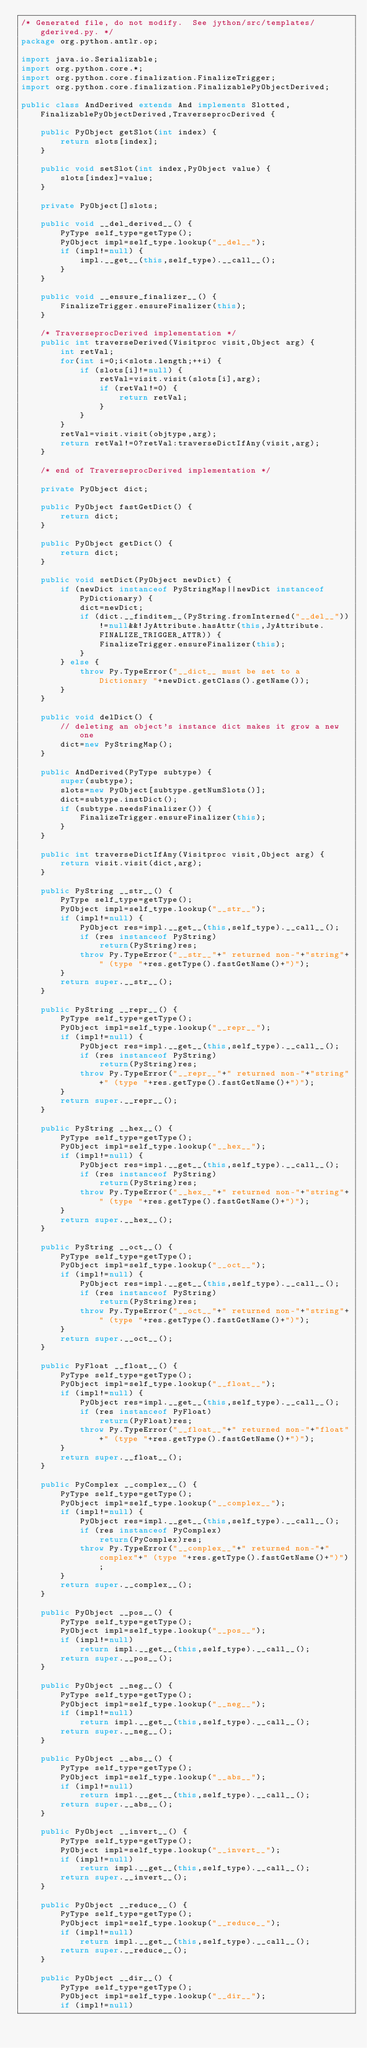Convert code to text. <code><loc_0><loc_0><loc_500><loc_500><_Java_>/* Generated file, do not modify.  See jython/src/templates/gderived.py. */
package org.python.antlr.op;

import java.io.Serializable;
import org.python.core.*;
import org.python.core.finalization.FinalizeTrigger;
import org.python.core.finalization.FinalizablePyObjectDerived;

public class AndDerived extends And implements Slotted,FinalizablePyObjectDerived,TraverseprocDerived {

    public PyObject getSlot(int index) {
        return slots[index];
    }

    public void setSlot(int index,PyObject value) {
        slots[index]=value;
    }

    private PyObject[]slots;

    public void __del_derived__() {
        PyType self_type=getType();
        PyObject impl=self_type.lookup("__del__");
        if (impl!=null) {
            impl.__get__(this,self_type).__call__();
        }
    }

    public void __ensure_finalizer__() {
        FinalizeTrigger.ensureFinalizer(this);
    }

    /* TraverseprocDerived implementation */
    public int traverseDerived(Visitproc visit,Object arg) {
        int retVal;
        for(int i=0;i<slots.length;++i) {
            if (slots[i]!=null) {
                retVal=visit.visit(slots[i],arg);
                if (retVal!=0) {
                    return retVal;
                }
            }
        }
        retVal=visit.visit(objtype,arg);
        return retVal!=0?retVal:traverseDictIfAny(visit,arg);
    }

    /* end of TraverseprocDerived implementation */

    private PyObject dict;

    public PyObject fastGetDict() {
        return dict;
    }

    public PyObject getDict() {
        return dict;
    }

    public void setDict(PyObject newDict) {
        if (newDict instanceof PyStringMap||newDict instanceof PyDictionary) {
            dict=newDict;
            if (dict.__finditem__(PyString.fromInterned("__del__"))!=null&&!JyAttribute.hasAttr(this,JyAttribute.FINALIZE_TRIGGER_ATTR)) {
                FinalizeTrigger.ensureFinalizer(this);
            }
        } else {
            throw Py.TypeError("__dict__ must be set to a Dictionary "+newDict.getClass().getName());
        }
    }

    public void delDict() {
        // deleting an object's instance dict makes it grow a new one
        dict=new PyStringMap();
    }

    public AndDerived(PyType subtype) {
        super(subtype);
        slots=new PyObject[subtype.getNumSlots()];
        dict=subtype.instDict();
        if (subtype.needsFinalizer()) {
            FinalizeTrigger.ensureFinalizer(this);
        }
    }

    public int traverseDictIfAny(Visitproc visit,Object arg) {
        return visit.visit(dict,arg);
    }

    public PyString __str__() {
        PyType self_type=getType();
        PyObject impl=self_type.lookup("__str__");
        if (impl!=null) {
            PyObject res=impl.__get__(this,self_type).__call__();
            if (res instanceof PyString)
                return(PyString)res;
            throw Py.TypeError("__str__"+" returned non-"+"string"+" (type "+res.getType().fastGetName()+")");
        }
        return super.__str__();
    }

    public PyString __repr__() {
        PyType self_type=getType();
        PyObject impl=self_type.lookup("__repr__");
        if (impl!=null) {
            PyObject res=impl.__get__(this,self_type).__call__();
            if (res instanceof PyString)
                return(PyString)res;
            throw Py.TypeError("__repr__"+" returned non-"+"string"+" (type "+res.getType().fastGetName()+")");
        }
        return super.__repr__();
    }

    public PyString __hex__() {
        PyType self_type=getType();
        PyObject impl=self_type.lookup("__hex__");
        if (impl!=null) {
            PyObject res=impl.__get__(this,self_type).__call__();
            if (res instanceof PyString)
                return(PyString)res;
            throw Py.TypeError("__hex__"+" returned non-"+"string"+" (type "+res.getType().fastGetName()+")");
        }
        return super.__hex__();
    }

    public PyString __oct__() {
        PyType self_type=getType();
        PyObject impl=self_type.lookup("__oct__");
        if (impl!=null) {
            PyObject res=impl.__get__(this,self_type).__call__();
            if (res instanceof PyString)
                return(PyString)res;
            throw Py.TypeError("__oct__"+" returned non-"+"string"+" (type "+res.getType().fastGetName()+")");
        }
        return super.__oct__();
    }

    public PyFloat __float__() {
        PyType self_type=getType();
        PyObject impl=self_type.lookup("__float__");
        if (impl!=null) {
            PyObject res=impl.__get__(this,self_type).__call__();
            if (res instanceof PyFloat)
                return(PyFloat)res;
            throw Py.TypeError("__float__"+" returned non-"+"float"+" (type "+res.getType().fastGetName()+")");
        }
        return super.__float__();
    }

    public PyComplex __complex__() {
        PyType self_type=getType();
        PyObject impl=self_type.lookup("__complex__");
        if (impl!=null) {
            PyObject res=impl.__get__(this,self_type).__call__();
            if (res instanceof PyComplex)
                return(PyComplex)res;
            throw Py.TypeError("__complex__"+" returned non-"+"complex"+" (type "+res.getType().fastGetName()+")");
        }
        return super.__complex__();
    }

    public PyObject __pos__() {
        PyType self_type=getType();
        PyObject impl=self_type.lookup("__pos__");
        if (impl!=null)
            return impl.__get__(this,self_type).__call__();
        return super.__pos__();
    }

    public PyObject __neg__() {
        PyType self_type=getType();
        PyObject impl=self_type.lookup("__neg__");
        if (impl!=null)
            return impl.__get__(this,self_type).__call__();
        return super.__neg__();
    }

    public PyObject __abs__() {
        PyType self_type=getType();
        PyObject impl=self_type.lookup("__abs__");
        if (impl!=null)
            return impl.__get__(this,self_type).__call__();
        return super.__abs__();
    }

    public PyObject __invert__() {
        PyType self_type=getType();
        PyObject impl=self_type.lookup("__invert__");
        if (impl!=null)
            return impl.__get__(this,self_type).__call__();
        return super.__invert__();
    }

    public PyObject __reduce__() {
        PyType self_type=getType();
        PyObject impl=self_type.lookup("__reduce__");
        if (impl!=null)
            return impl.__get__(this,self_type).__call__();
        return super.__reduce__();
    }

    public PyObject __dir__() {
        PyType self_type=getType();
        PyObject impl=self_type.lookup("__dir__");
        if (impl!=null)</code> 